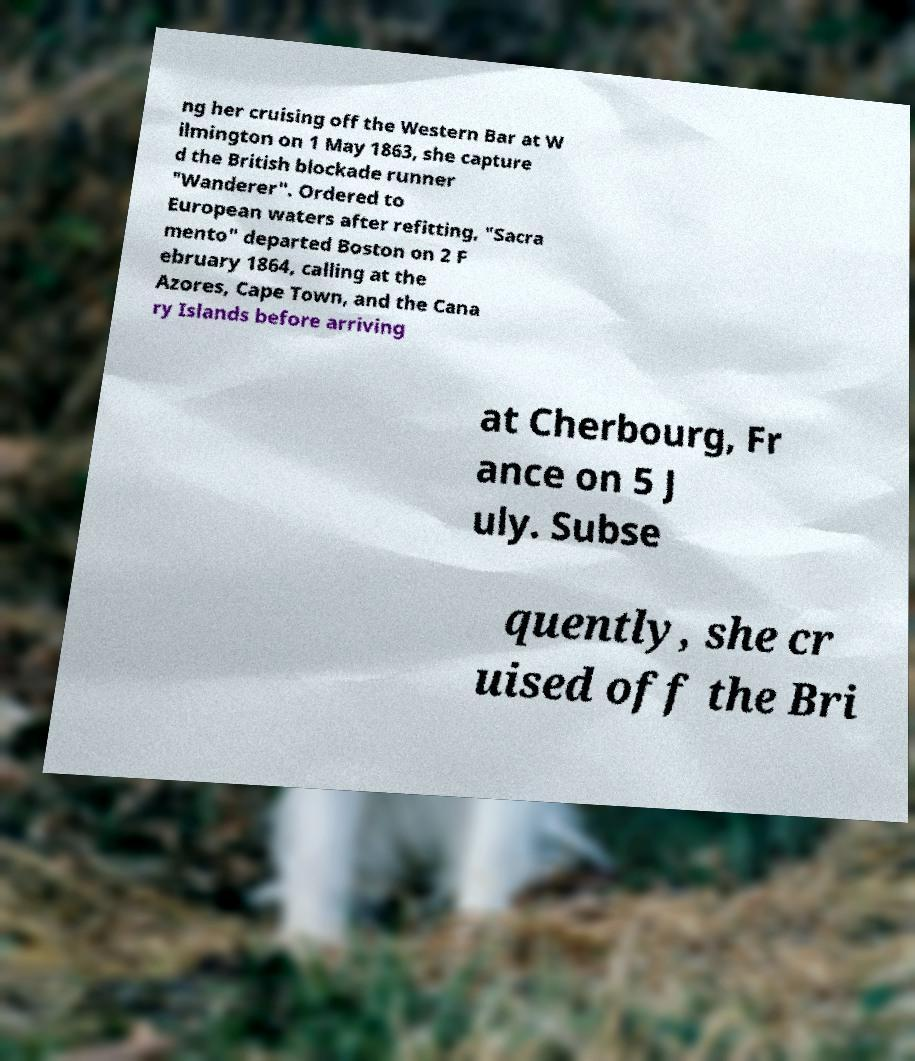For documentation purposes, I need the text within this image transcribed. Could you provide that? ng her cruising off the Western Bar at W ilmington on 1 May 1863, she capture d the British blockade runner "Wanderer". Ordered to European waters after refitting, "Sacra mento" departed Boston on 2 F ebruary 1864, calling at the Azores, Cape Town, and the Cana ry Islands before arriving at Cherbourg, Fr ance on 5 J uly. Subse quently, she cr uised off the Bri 